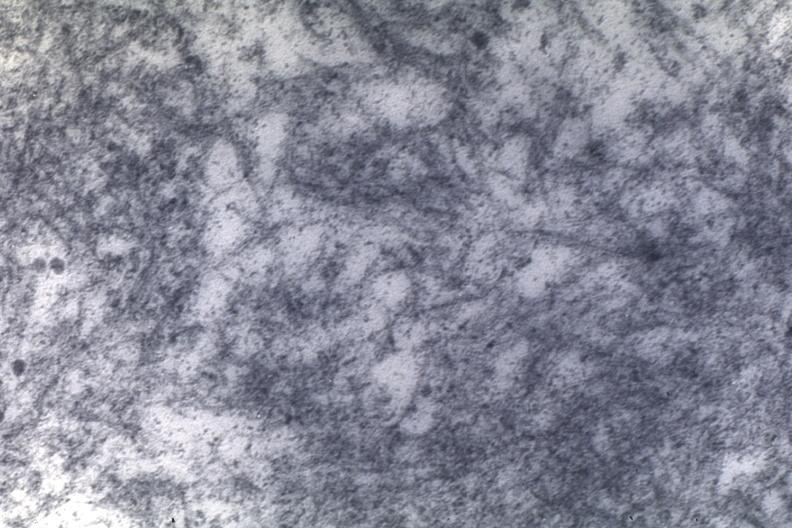where is this area in the body?
Answer the question using a single word or phrase. Heart 